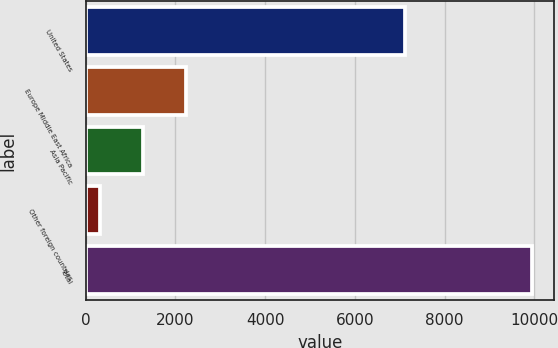Convert chart. <chart><loc_0><loc_0><loc_500><loc_500><bar_chart><fcel>United States<fcel>Europe Middle East Africa<fcel>Asia Pacific<fcel>Other foreign countries<fcel>Total<nl><fcel>7116<fcel>2238.8<fcel>1275.4<fcel>312<fcel>9946<nl></chart> 